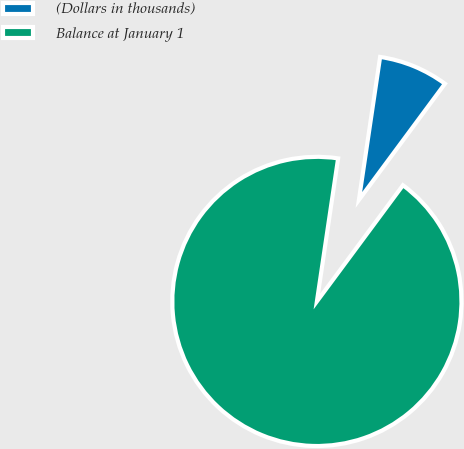Convert chart to OTSL. <chart><loc_0><loc_0><loc_500><loc_500><pie_chart><fcel>(Dollars in thousands)<fcel>Balance at January 1<nl><fcel>7.8%<fcel>92.2%<nl></chart> 